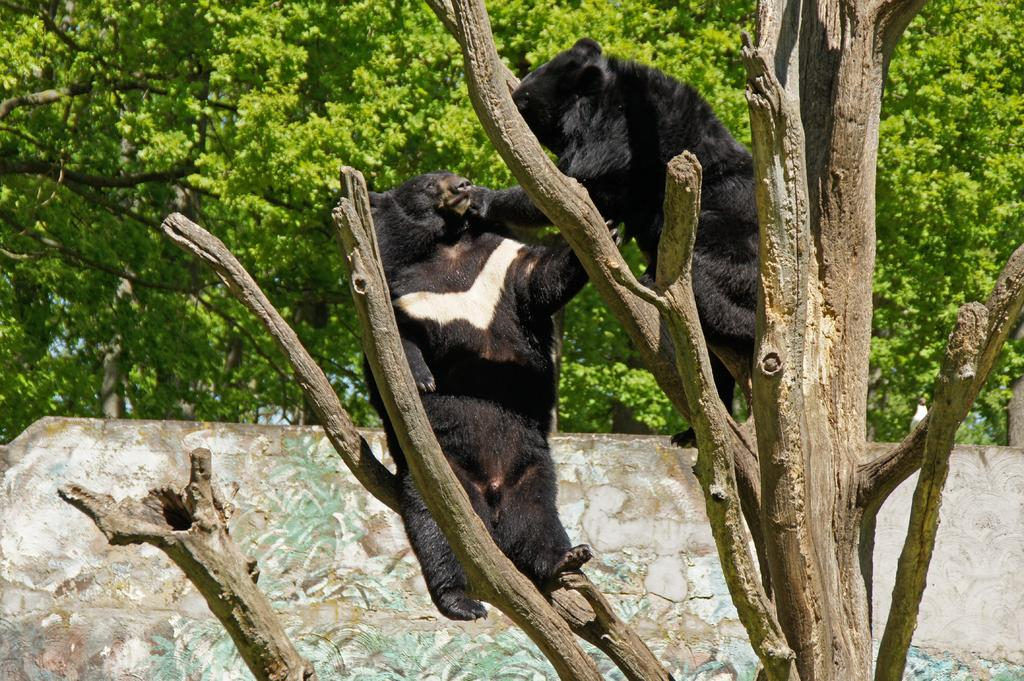What is happening in the image involving animals? There are animals on a tree in the image. What can be seen in the background of the image? There is a wall and a group of trees visible in the background of the image. What type of instrument is the cook using to sort the vegetables in the image? There is no cook, instrument, or vegetables present in the image. 